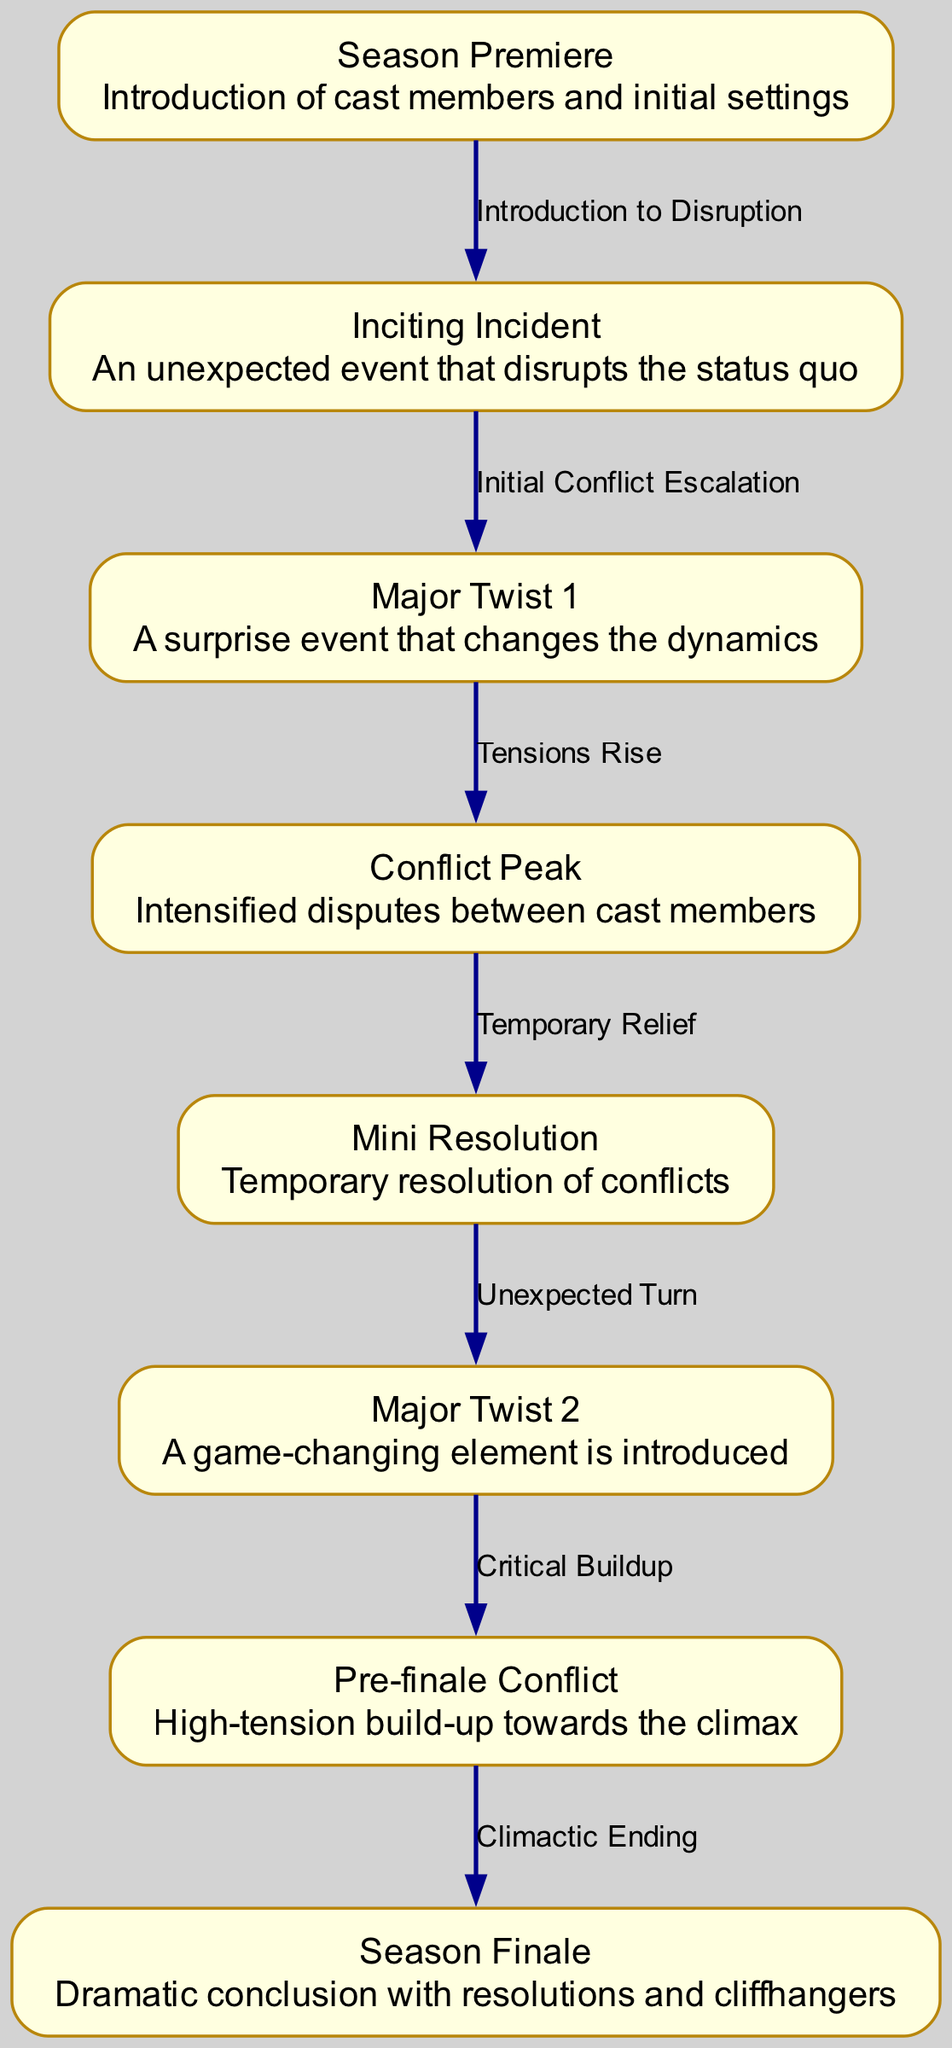What is the starting point of the plot structure? The starting point of the plot structure is represented by the node labeled "Season Premiere," which introduces cast members and initial settings.
Answer: Season Premiere How many major twists are shown in the diagram? The diagram indicates there are two major twists, "Major Twist 1" and "Major Twist 2."
Answer: 2 What is the label of the node that follows "Major Twist 1"? "Major Twist 1" is followed by the node labeled "Conflict Peak," indicating heightened tensions between cast members.
Answer: Conflict Peak What relationship connects "Mini Resolution" and "Major Twist 2"? The relationship is labeled "Unexpected Turn," indicating that after a temporary resolution, an unexpected event is introduced.
Answer: Unexpected Turn Which node represents the season's climax? The node representing the season's climax is labeled "Season Finale," where dramatic resolutions and cliffhangers occur.
Answer: Season Finale Which edge signifies the transition from intro to disruption? The edge connecting "start" and "inciting_incident" signifies the transition labeled "Introduction to Disruption," showcasing how the initial setup is interrupted.
Answer: Introduction to Disruption What occurs after the "Conflict Peak"? After the "Conflict Peak," there is a node labeled "Mini Resolution," which indicates a temporary resolution of conflicts before further developments arise.
Answer: Mini Resolution What two elements lead up to the climactic ending? "Pre-finale Conflict" leads to the "Season Finale," indicating a buildup of tension towards the concluding events.
Answer: Pre-finale Conflict and Season Finale What is described by the node "Inciting Incident"? The node "Inciting Incident" describes an unexpected event that disrupts the status quo established at the beginning of the season.
Answer: An unexpected event that disrupts the status quo 